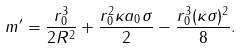<formula> <loc_0><loc_0><loc_500><loc_500>m ^ { \prime } = \frac { r _ { 0 } ^ { 3 } } { 2 R ^ { 2 } } + \frac { r _ { 0 } ^ { 2 } \kappa a _ { 0 } \sigma } { 2 } - \frac { r _ { 0 } ^ { 3 } ( \kappa \sigma ) ^ { 2 } } { 8 } .</formula> 